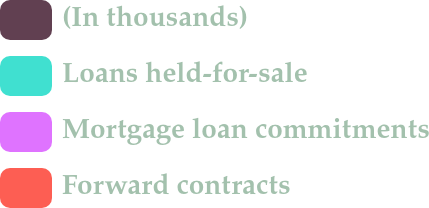<chart> <loc_0><loc_0><loc_500><loc_500><pie_chart><fcel>(In thousands)<fcel>Loans held-for-sale<fcel>Mortgage loan commitments<fcel>Forward contracts<nl><fcel>9.4%<fcel>49.47%<fcel>36.17%<fcel>4.95%<nl></chart> 